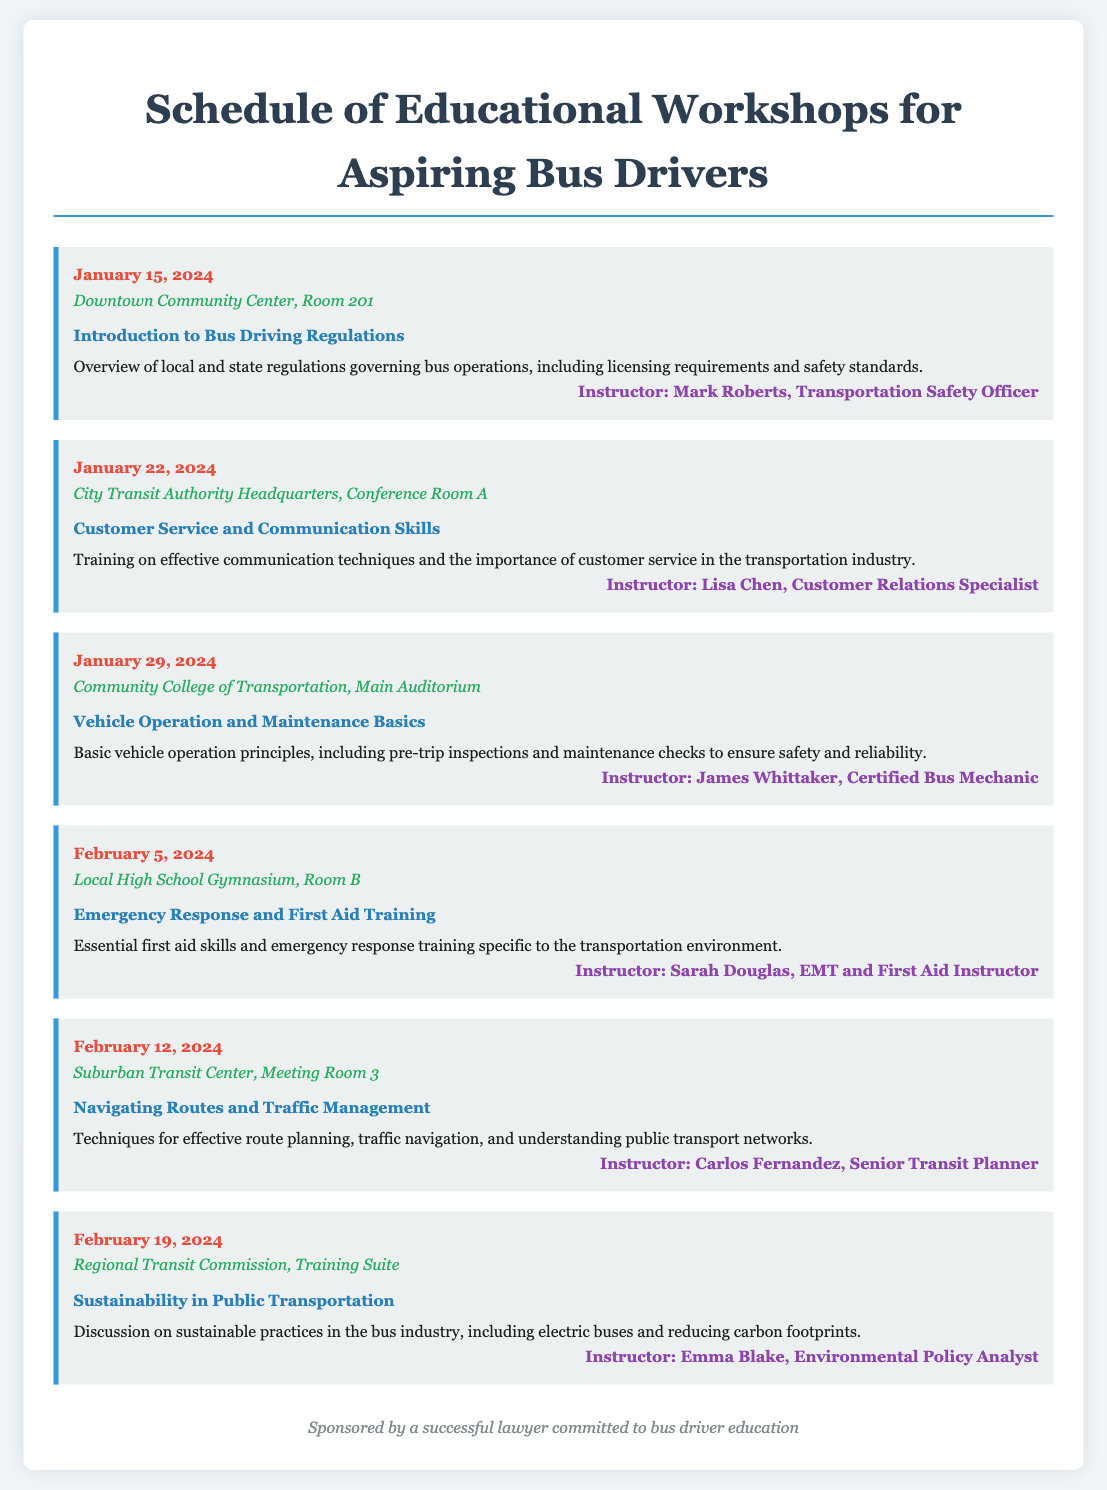What is the date of the first workshop? The first workshop is scheduled for January 15, 2024, as indicated in the document.
Answer: January 15, 2024 Where will the second workshop take place? The location of the second workshop is specified as City Transit Authority Headquarters, Conference Room A.
Answer: City Transit Authority Headquarters, Conference Room A Who is the instructor for the emergency response workshop? The instructor for the emergency response workshop is named in the document as Sarah Douglas, EMT and First Aid Instructor.
Answer: Sarah Douglas How many workshops are scheduled in February 2024? The document lists three workshops scheduled for February 2024: on February 5, 12, and 19.
Answer: Three What is the main topic of the last workshop? The last workshop focuses on sustainability in public transportation, as described in the document.
Answer: Sustainability in Public Transportation Which workshop deals with vehicle operation? The workshop that deals with vehicle operation is titled "Vehicle Operation and Maintenance Basics."
Answer: Vehicle Operation and Maintenance Basics What is the focus of the workshop on January 22? The focus of the workshop on January 22 is on customer service and communication skills, as mentioned in the document.
Answer: Customer Service and Communication Skills How many total workshops are listed? The document details a total of six workshops in its schedule.
Answer: Six 